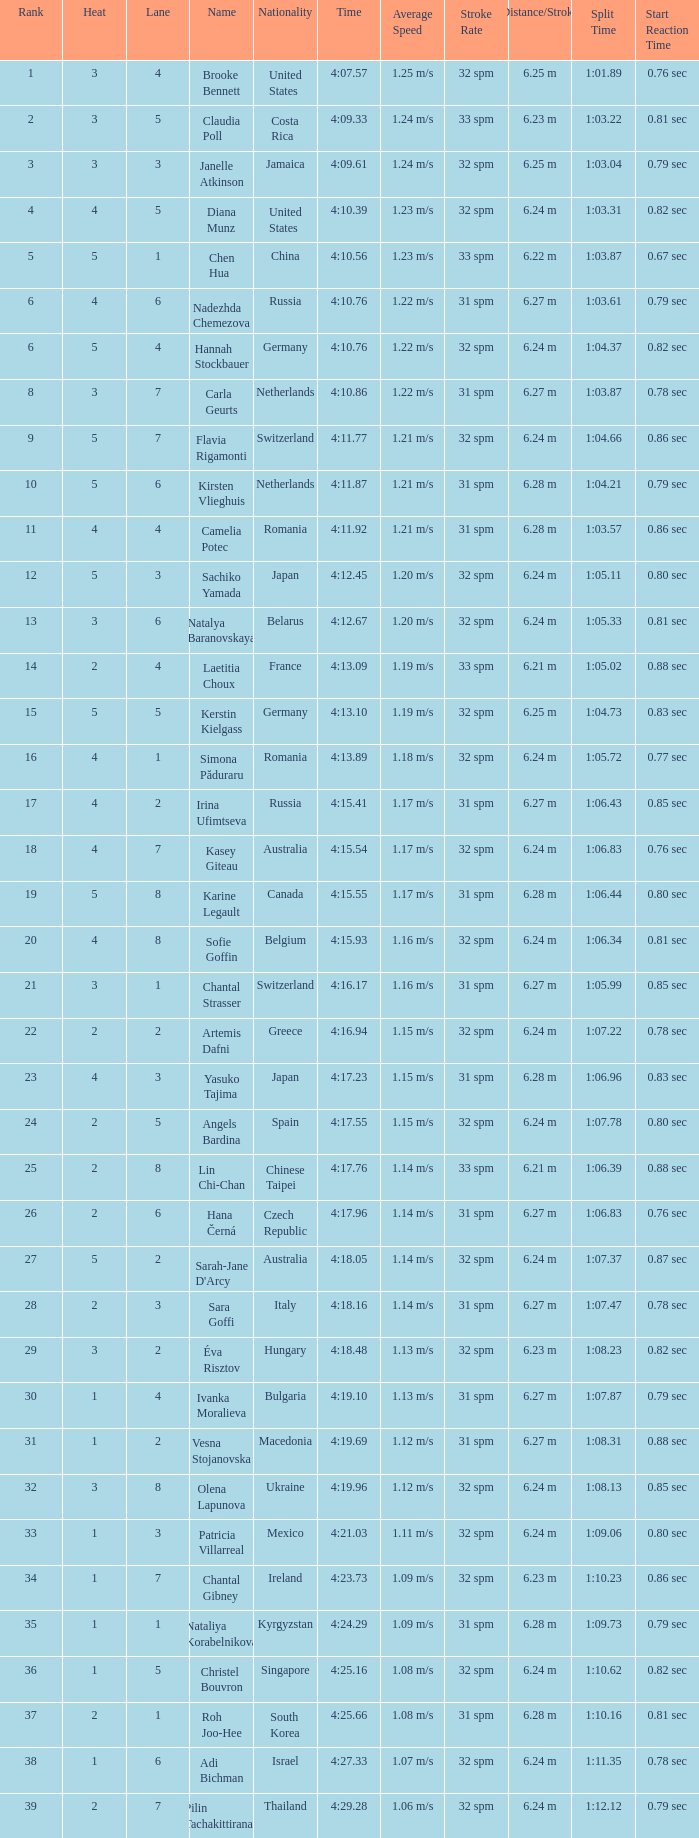Name the least lane for kasey giteau and rank less than 18 None. 